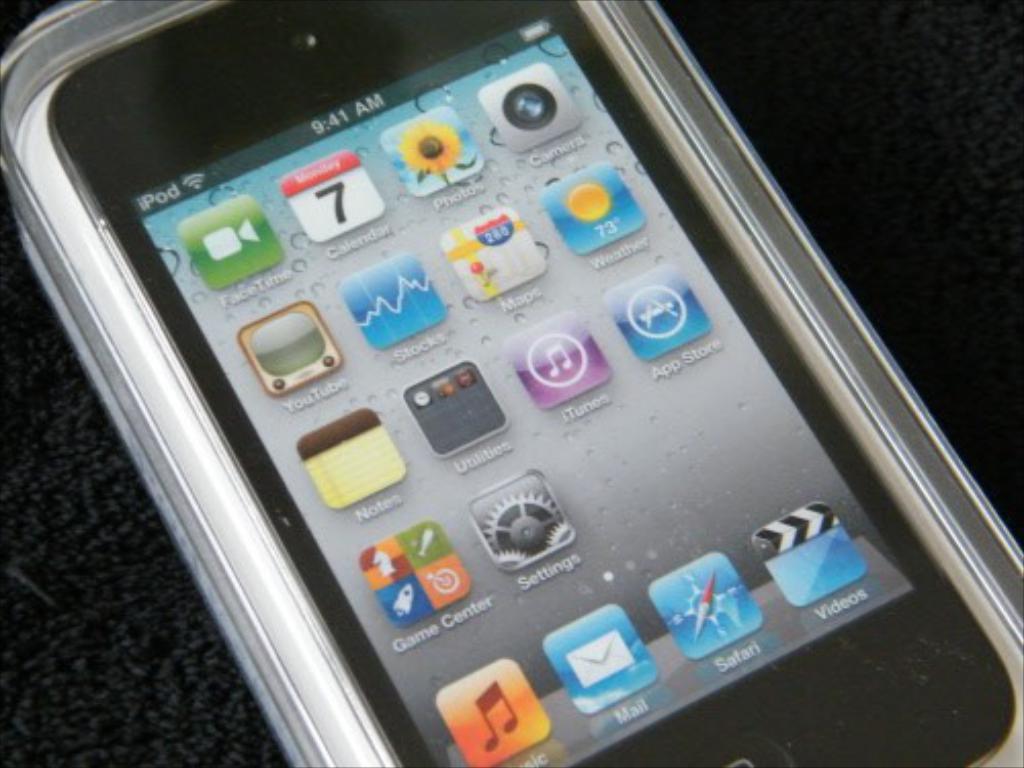What is this?
Keep it short and to the point. Answering does not require reading text in the image. What is the name of the first app in the top left?
Provide a short and direct response. Facetime. 